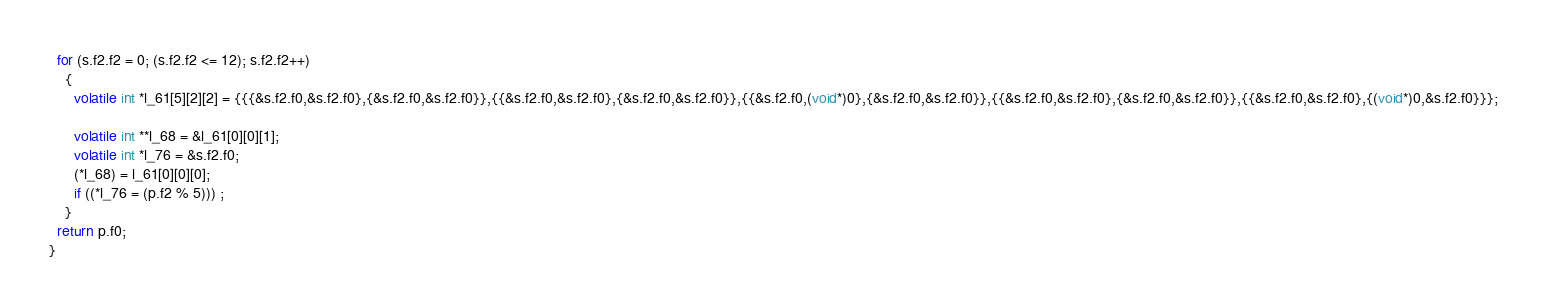<code> <loc_0><loc_0><loc_500><loc_500><_C_>  for (s.f2.f2 = 0; (s.f2.f2 <= 12); s.f2.f2++)
    {
      volatile int *l_61[5][2][2] = {{{&s.f2.f0,&s.f2.f0},{&s.f2.f0,&s.f2.f0}},{{&s.f2.f0,&s.f2.f0},{&s.f2.f0,&s.f2.f0}},{{&s.f2.f0,(void*)0},{&s.f2.f0,&s.f2.f0}},{{&s.f2.f0,&s.f2.f0},{&s.f2.f0,&s.f2.f0}},{{&s.f2.f0,&s.f2.f0},{(void*)0,&s.f2.f0}}};

      volatile int **l_68 = &l_61[0][0][1];
      volatile int *l_76 = &s.f2.f0;
      (*l_68) = l_61[0][0][0];
      if ((*l_76 = (p.f2 % 5))) ;
    }
  return p.f0;
}
</code> 